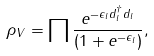<formula> <loc_0><loc_0><loc_500><loc_500>\rho _ { V } = \prod \frac { e ^ { - \epsilon _ { l } d _ { l } ^ { \dagger } d _ { l } } } { \left ( 1 + e ^ { - \epsilon _ { l } } \right ) } ,</formula> 